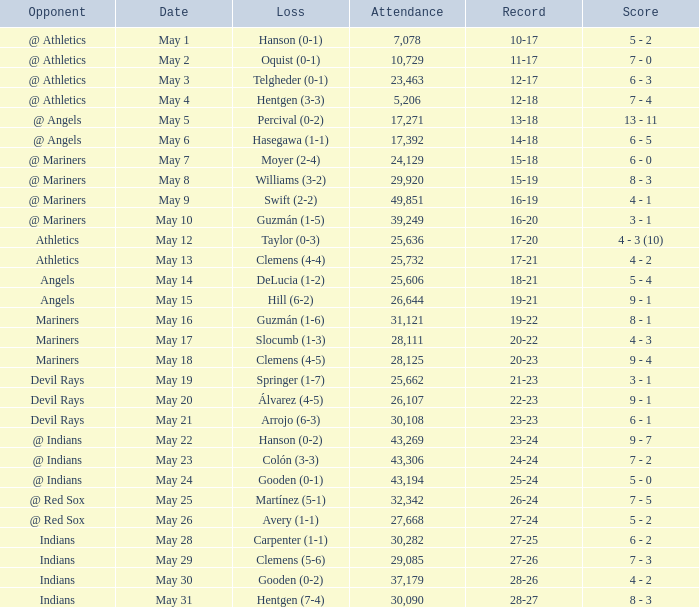What is the record for May 31? 28-27. 